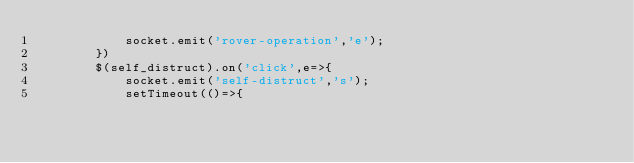Convert code to text. <code><loc_0><loc_0><loc_500><loc_500><_JavaScript_>            socket.emit('rover-operation','e');
        })
        $(self_distruct).on('click',e=>{
            socket.emit('self-distruct','s');
            setTimeout(()=>{</code> 